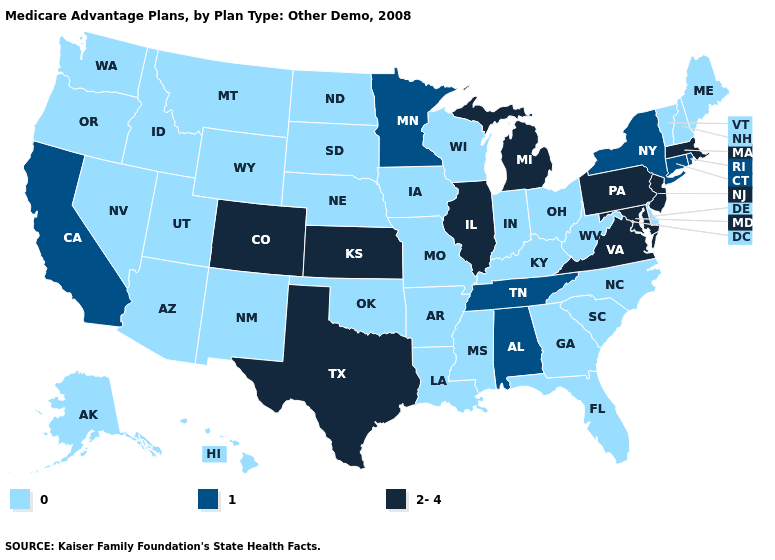Name the states that have a value in the range 2-4?
Keep it brief. Colorado, Illinois, Kansas, Massachusetts, Maryland, Michigan, New Jersey, Pennsylvania, Texas, Virginia. Name the states that have a value in the range 0?
Answer briefly. Alaska, Arkansas, Arizona, Delaware, Florida, Georgia, Hawaii, Iowa, Idaho, Indiana, Kentucky, Louisiana, Maine, Missouri, Mississippi, Montana, North Carolina, North Dakota, Nebraska, New Hampshire, New Mexico, Nevada, Ohio, Oklahoma, Oregon, South Carolina, South Dakota, Utah, Vermont, Washington, Wisconsin, West Virginia, Wyoming. Name the states that have a value in the range 1?
Concise answer only. Alabama, California, Connecticut, Minnesota, New York, Rhode Island, Tennessee. Name the states that have a value in the range 0?
Write a very short answer. Alaska, Arkansas, Arizona, Delaware, Florida, Georgia, Hawaii, Iowa, Idaho, Indiana, Kentucky, Louisiana, Maine, Missouri, Mississippi, Montana, North Carolina, North Dakota, Nebraska, New Hampshire, New Mexico, Nevada, Ohio, Oklahoma, Oregon, South Carolina, South Dakota, Utah, Vermont, Washington, Wisconsin, West Virginia, Wyoming. Does Georgia have a lower value than Florida?
Write a very short answer. No. Which states have the highest value in the USA?
Concise answer only. Colorado, Illinois, Kansas, Massachusetts, Maryland, Michigan, New Jersey, Pennsylvania, Texas, Virginia. What is the value of Maine?
Write a very short answer. 0. Does Minnesota have the highest value in the USA?
Answer briefly. No. Name the states that have a value in the range 2-4?
Concise answer only. Colorado, Illinois, Kansas, Massachusetts, Maryland, Michigan, New Jersey, Pennsylvania, Texas, Virginia. What is the value of South Dakota?
Write a very short answer. 0. What is the lowest value in states that border Kansas?
Short answer required. 0. Which states hav the highest value in the MidWest?
Give a very brief answer. Illinois, Kansas, Michigan. Does the map have missing data?
Quick response, please. No. Does Arkansas have the same value as California?
Be succinct. No. 